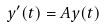Convert formula to latex. <formula><loc_0><loc_0><loc_500><loc_500>y ^ { \prime } ( t ) = A y ( t )</formula> 